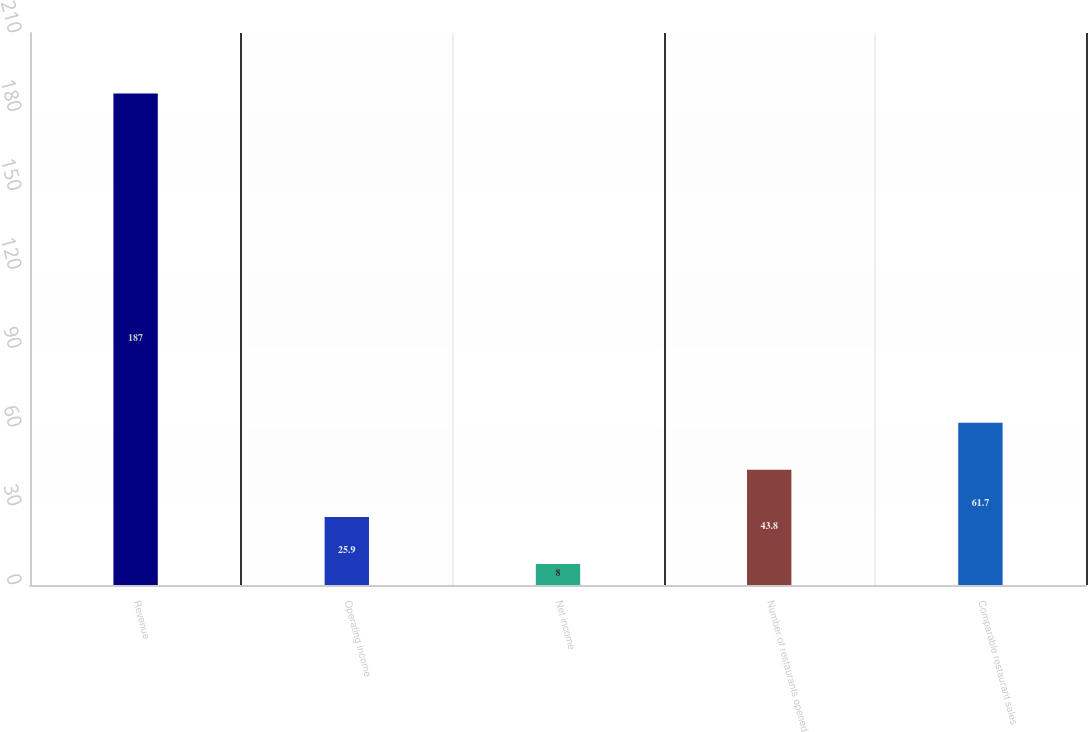Convert chart. <chart><loc_0><loc_0><loc_500><loc_500><bar_chart><fcel>Revenue<fcel>Operating income<fcel>Net income<fcel>Number of restaurants opened<fcel>Comparable restaurant sales<nl><fcel>187<fcel>25.9<fcel>8<fcel>43.8<fcel>61.7<nl></chart> 